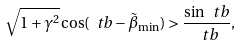<formula> <loc_0><loc_0><loc_500><loc_500>\sqrt { 1 + \gamma ^ { 2 } } \cos ( \ t b - \tilde { \beta } _ { \min } ) > \frac { \sin \ t b } { \ t b } ,</formula> 